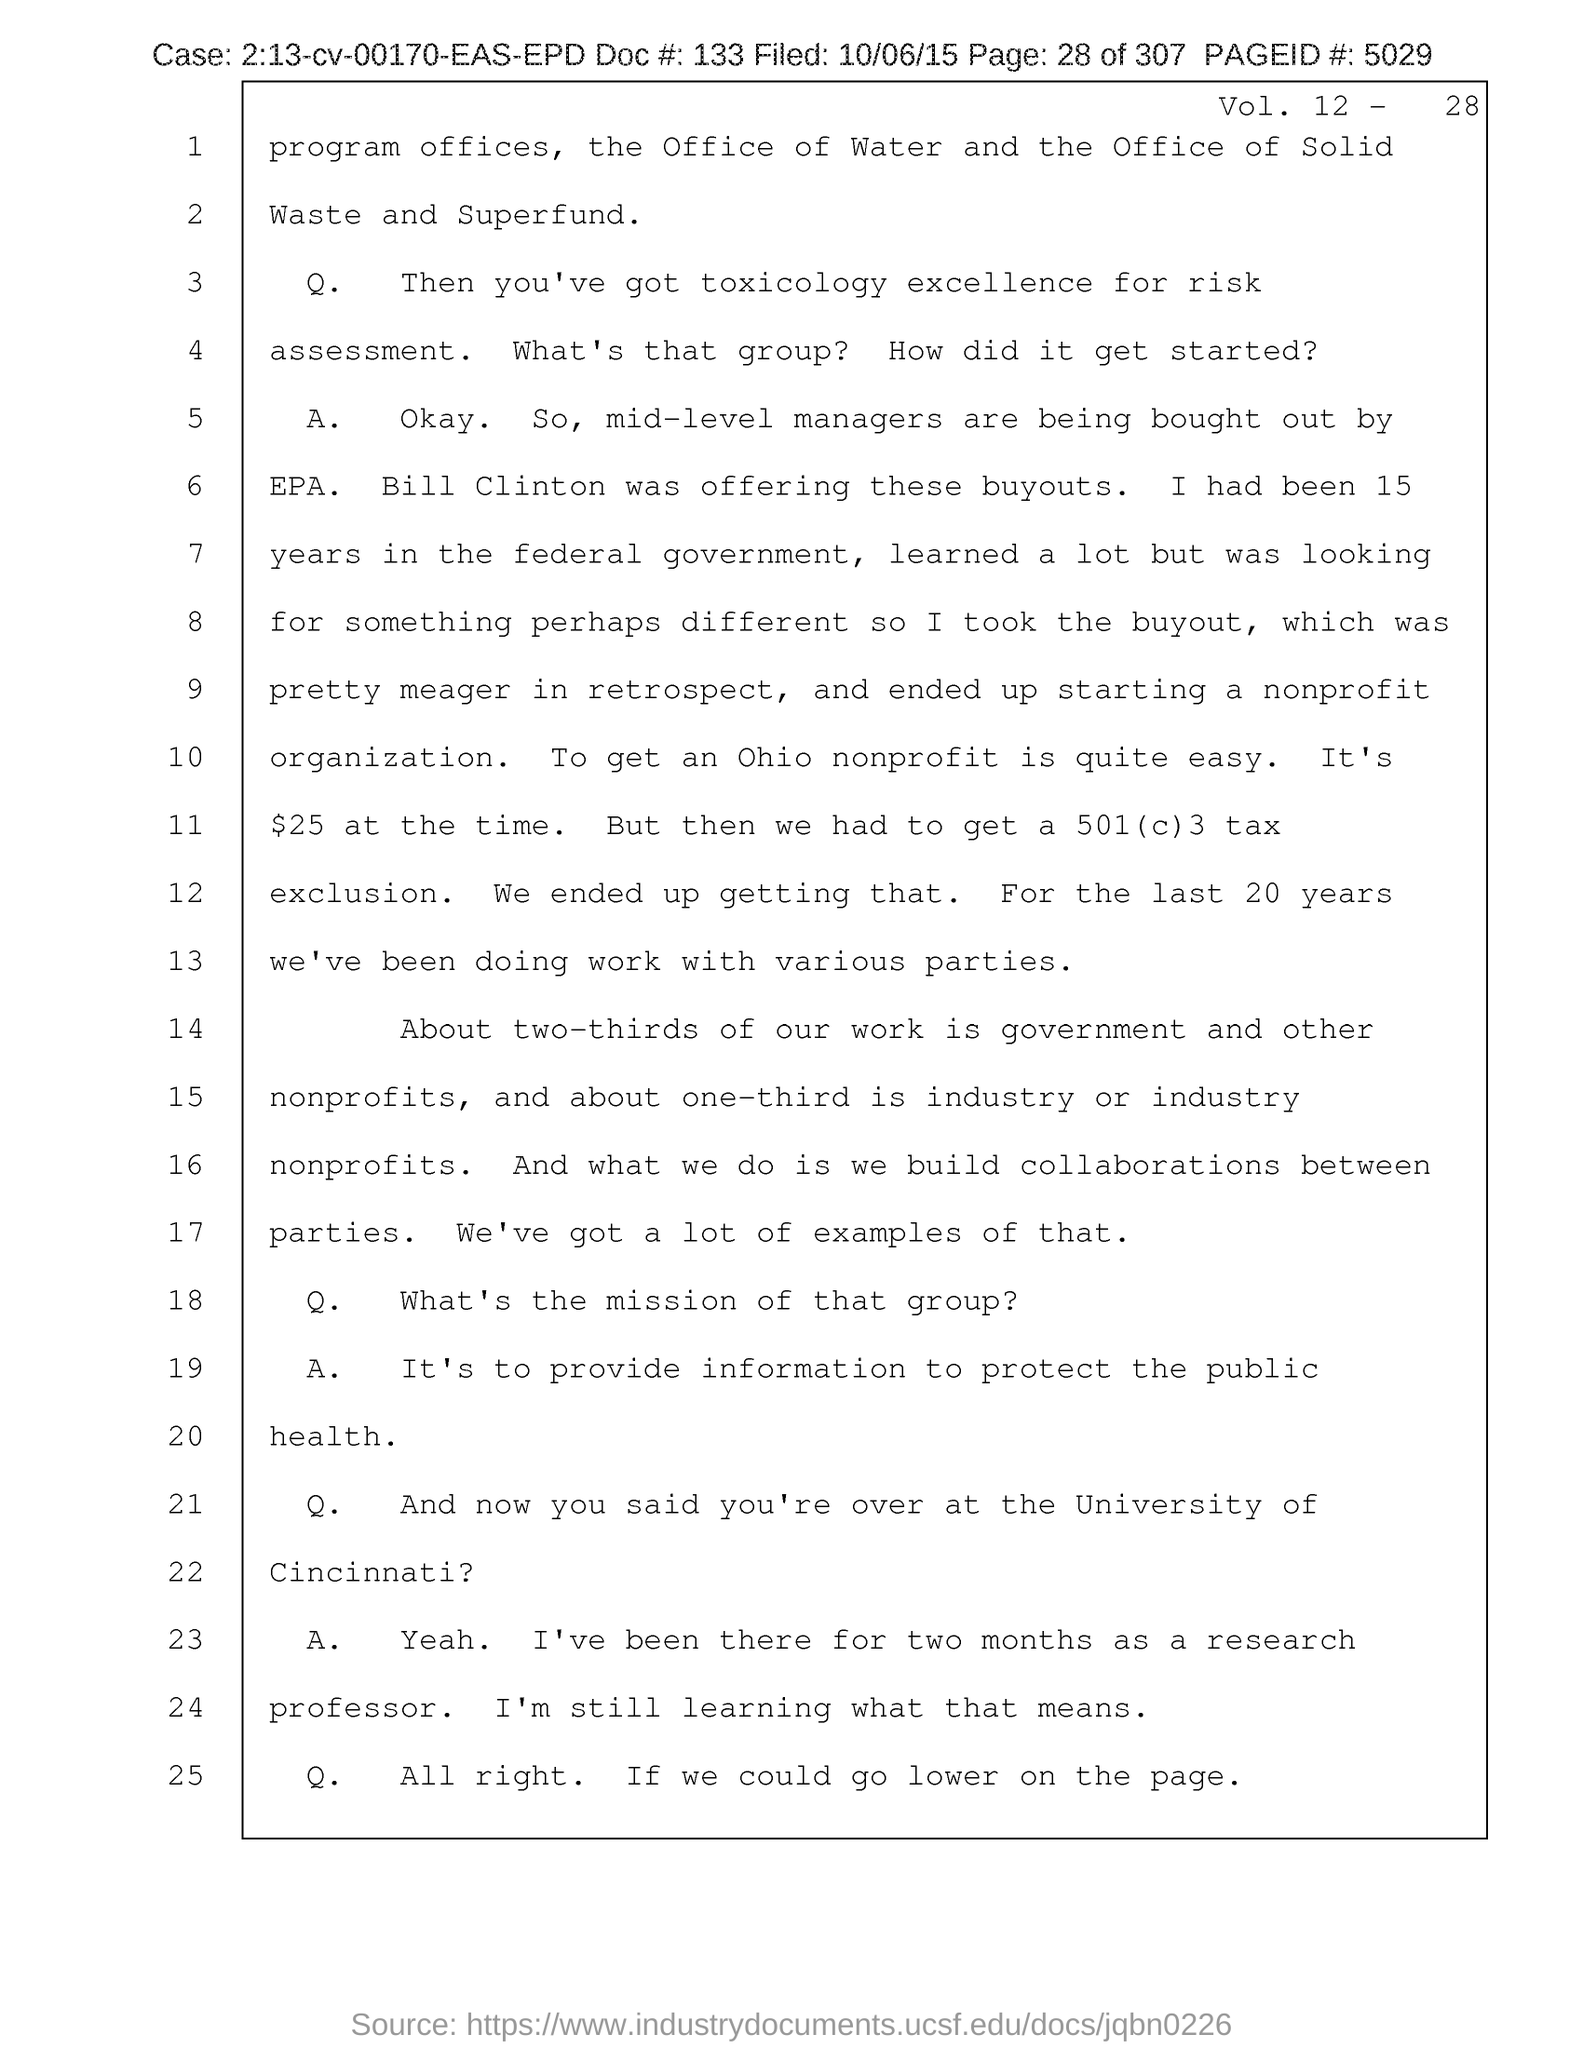What is the Page ID # mentioned in the document?
Provide a short and direct response. 5029. What is the doc # given in the document?
Your answer should be very brief. 133. What is the filed date of the document?
Keep it short and to the point. 10/06/15. What is the page no mentioned in this document?
Provide a short and direct response. 28 of 307. What is the Vol. no. given in the document?
Ensure brevity in your answer.  12 - 28. 